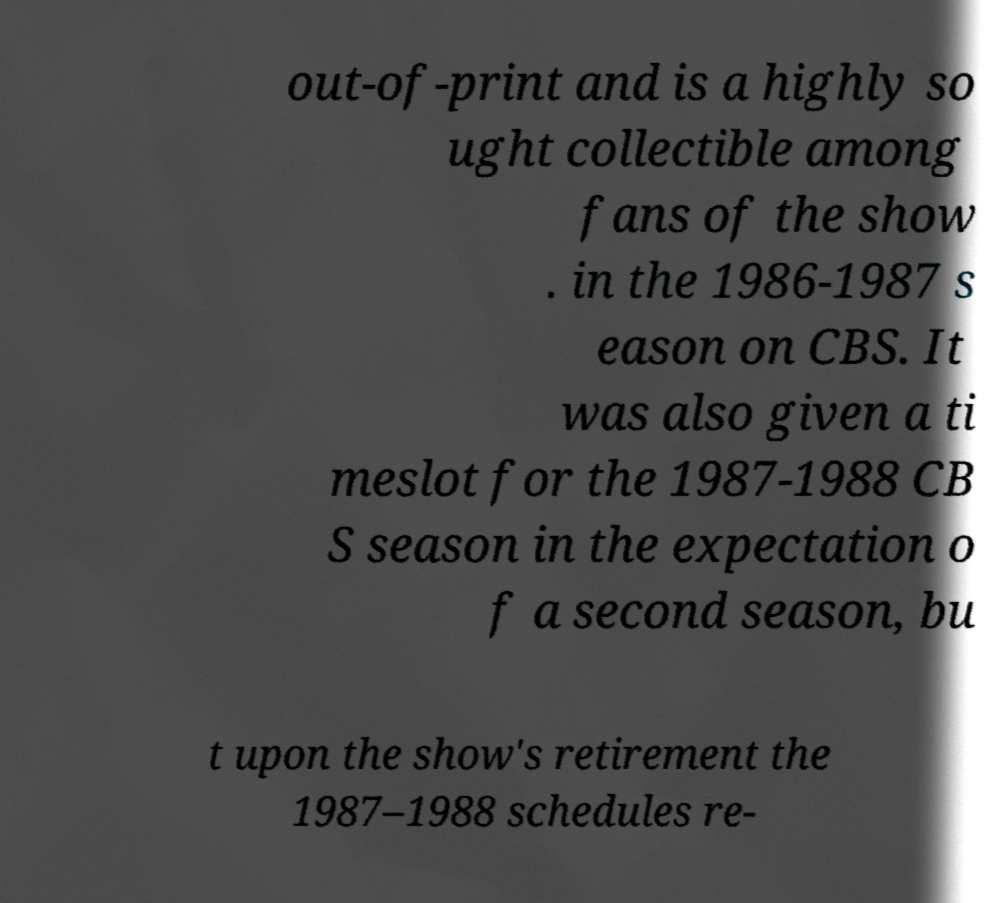For documentation purposes, I need the text within this image transcribed. Could you provide that? out-of-print and is a highly so ught collectible among fans of the show . in the 1986-1987 s eason on CBS. It was also given a ti meslot for the 1987-1988 CB S season in the expectation o f a second season, bu t upon the show's retirement the 1987–1988 schedules re- 